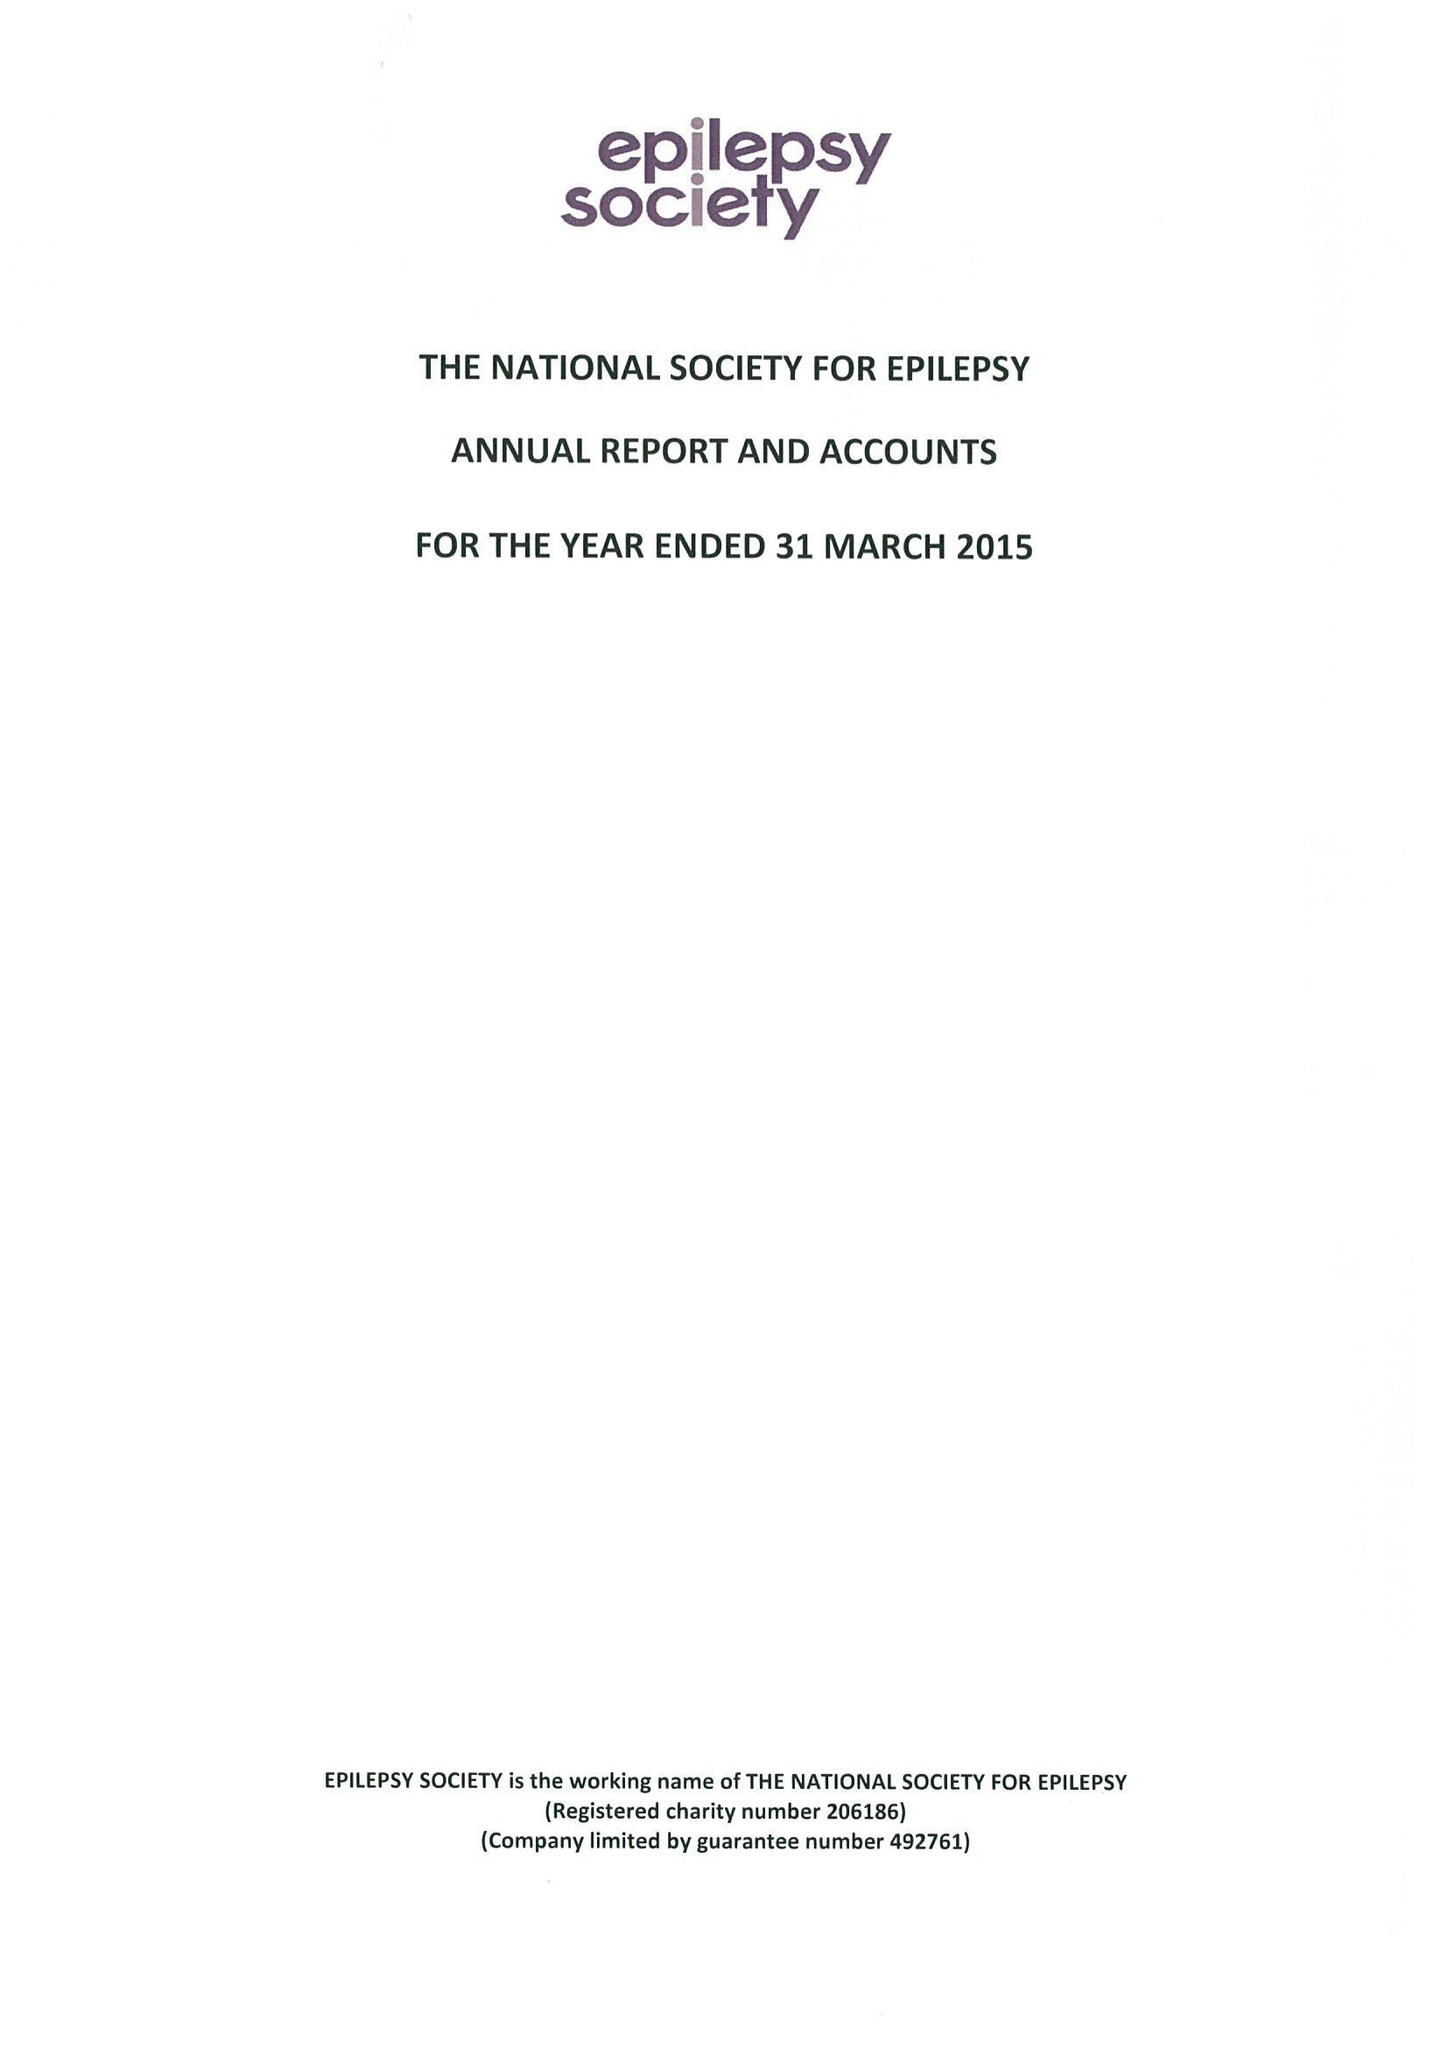What is the value for the report_date?
Answer the question using a single word or phrase. 2015-03-31 